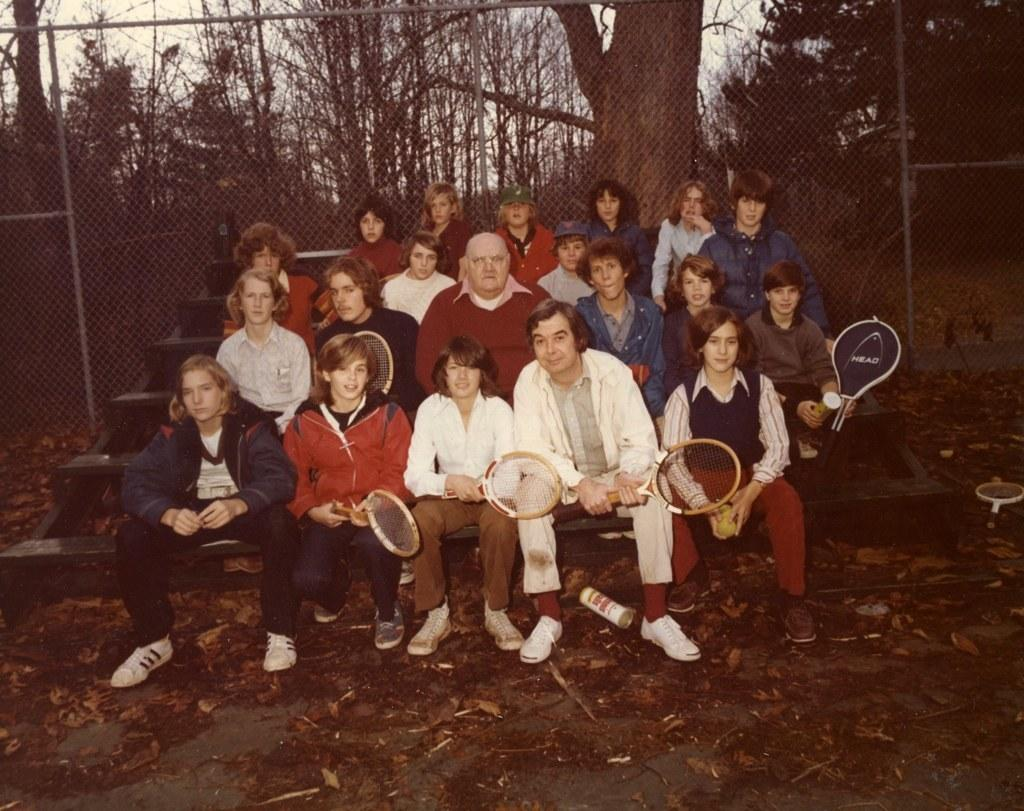How many people are in the image? There is a group of people in the image. What are the people doing in the image? The people are sitting on the stairs and holding rackets. What can be seen in the background of the image? There are trees, leaves, a fence, and the sky visible in the background of the image. What type of record is being played by the people in the image? There is no record or music player visible in the image; the people are holding rackets. Can you see an arch in the image? There is no arch present in the image. 